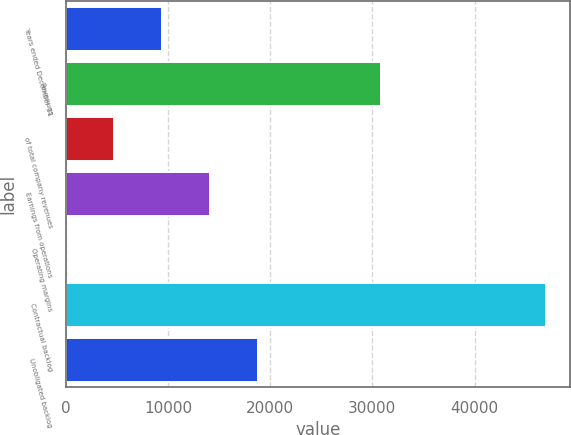<chart> <loc_0><loc_0><loc_500><loc_500><bar_chart><fcel>Years ended December 31<fcel>Revenues<fcel>of total company revenues<fcel>Earnings from operations<fcel>Operating margins<fcel>Contractual backlog<fcel>Unobligated backlog<nl><fcel>9402.88<fcel>30881<fcel>4706.49<fcel>14099.3<fcel>10.1<fcel>46974<fcel>18795.7<nl></chart> 